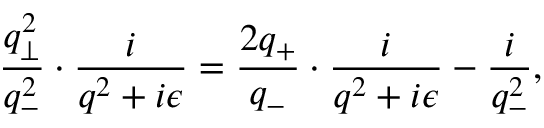Convert formula to latex. <formula><loc_0><loc_0><loc_500><loc_500>\frac { q _ { \bot } ^ { 2 } } { q _ { - } ^ { 2 } } \cdot \frac { i } { q ^ { 2 } + i { \epsilon } } = \frac { 2 q _ { + } } { q _ { - } } \cdot \frac { i } { q ^ { 2 } + i { \epsilon } } - \frac { i } { q _ { - } ^ { 2 } } ,</formula> 